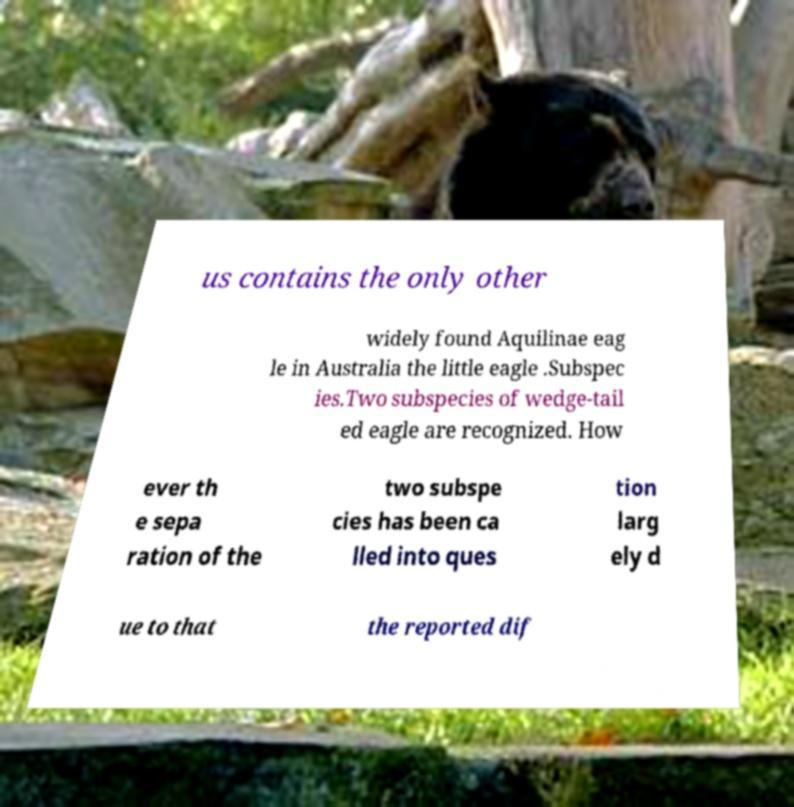What messages or text are displayed in this image? I need them in a readable, typed format. us contains the only other widely found Aquilinae eag le in Australia the little eagle .Subspec ies.Two subspecies of wedge-tail ed eagle are recognized. How ever th e sepa ration of the two subspe cies has been ca lled into ques tion larg ely d ue to that the reported dif 